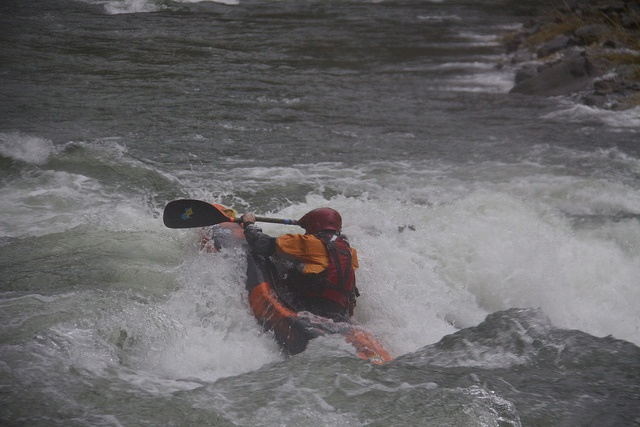Describe the objects in this image and their specific colors. I can see people in black, maroon, gray, and darkgray tones, boat in black, gray, brown, and maroon tones, and backpack in black, maroon, gray, and brown tones in this image. 